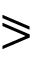<formula> <loc_0><loc_0><loc_500><loc_500>\ e q s l a n t g t r</formula> 